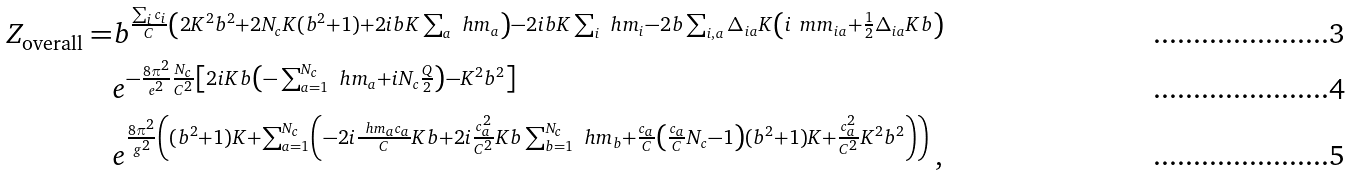<formula> <loc_0><loc_0><loc_500><loc_500>Z _ { \text {overall} } = & b ^ { \frac { \sum _ { i } c _ { i } } { C } \left ( 2 K ^ { 2 } b ^ { 2 } + 2 N _ { c } K ( b ^ { 2 } + 1 ) + 2 i b K \sum _ { a } \ h m _ { a } \right ) - 2 i b K \sum _ { i } \ h m _ { i } - 2 b \sum _ { i , a } \Delta _ { i a } K \left ( i \ m m _ { i a } + \frac { 1 } { 2 } \Delta _ { i a } K b \right ) } \\ & e ^ { - \frac { 8 \pi ^ { 2 } } { e ^ { 2 } } \frac { N _ { c } } { C ^ { 2 } } \left [ 2 i K b \left ( - \sum _ { a = 1 } ^ { N _ { c } } \ h m _ { a } + i N _ { c } \frac { Q } { 2 } \right ) - K ^ { 2 } b ^ { 2 } \right ] } \\ & e ^ { \frac { 8 \pi ^ { 2 } } { g ^ { 2 } } \left ( ( b ^ { 2 } + 1 ) K + \sum _ { a = 1 } ^ { N _ { c } } \left ( - 2 i \frac { \ h m _ { a } c _ { a } } { C } K b + 2 i \frac { c _ { a } ^ { 2 } } { C ^ { 2 } } K b \sum _ { b = 1 } ^ { N _ { c } } \ h m _ { b } + \frac { c _ { a } } { C } \left ( \frac { c _ { a } } { C } N _ { c } - 1 \right ) ( b ^ { 2 } + 1 ) K + \frac { c _ { a } ^ { 2 } } { C ^ { 2 } } K ^ { 2 } b ^ { 2 } \right ) \right ) } \, ,</formula> 